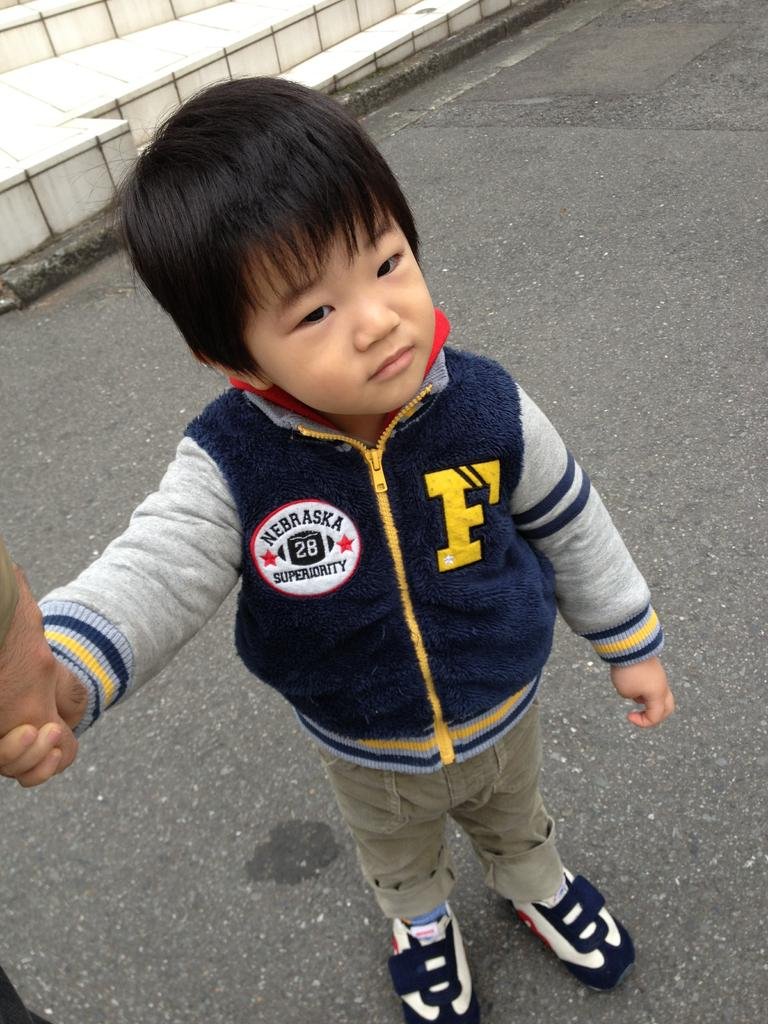<image>
Share a concise interpretation of the image provided. The little boy pictured has the state of Nebraska on his top. 